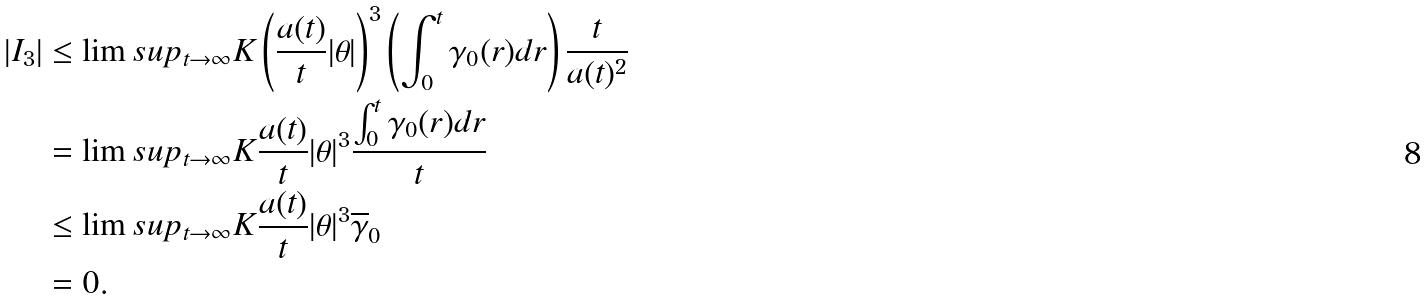<formula> <loc_0><loc_0><loc_500><loc_500>| I _ { 3 } | & \leq \lim s u p _ { t \rightarrow \infty } K \left ( \frac { a ( t ) } { t } | \theta | \right ) ^ { 3 } \left ( \int _ { 0 } ^ { t } \gamma _ { 0 } ( r ) d r \right ) \frac { t } { a ( t ) ^ { 2 } } \\ & = \lim s u p _ { t \rightarrow \infty } K \frac { a ( t ) } { t } | \theta | ^ { 3 } \frac { \int _ { 0 } ^ { t } \gamma _ { 0 } ( r ) d r } { t } \\ & \leq \lim s u p _ { t \rightarrow \infty } K \frac { a ( t ) } { t } | \theta | ^ { 3 } \overline { \gamma } _ { 0 } \\ & = 0 .</formula> 